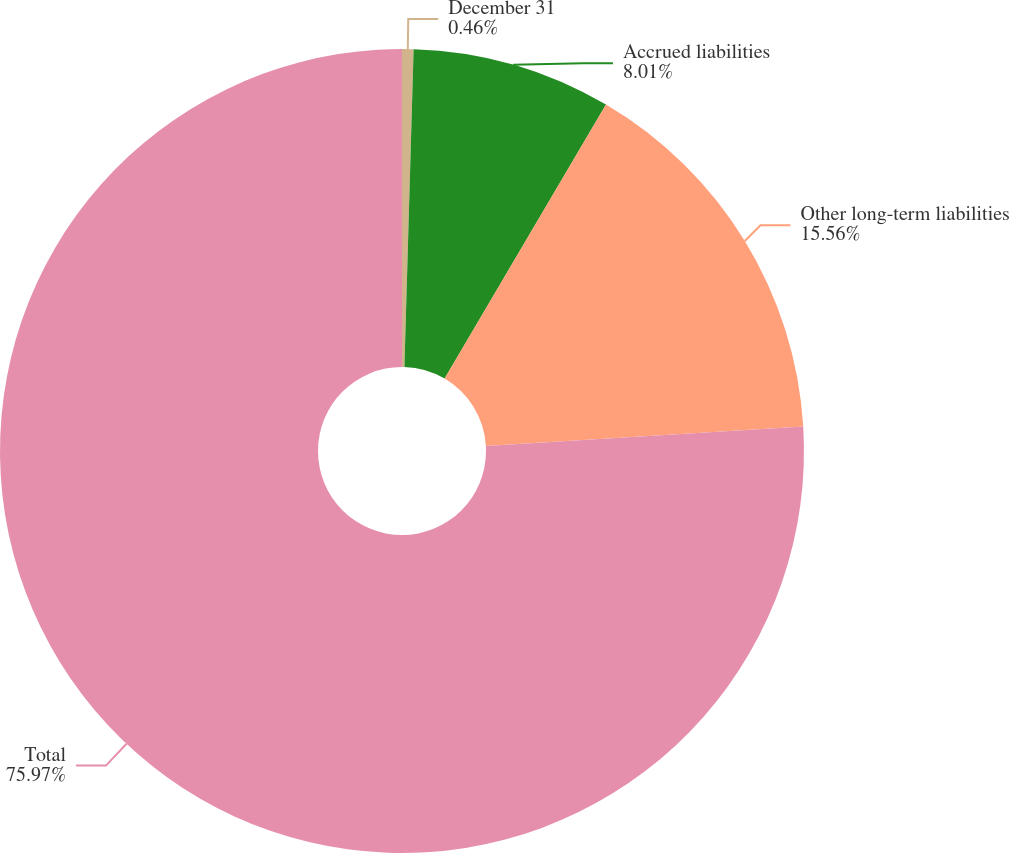Convert chart to OTSL. <chart><loc_0><loc_0><loc_500><loc_500><pie_chart><fcel>December 31<fcel>Accrued liabilities<fcel>Other long-term liabilities<fcel>Total<nl><fcel>0.46%<fcel>8.01%<fcel>15.56%<fcel>75.96%<nl></chart> 